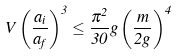Convert formula to latex. <formula><loc_0><loc_0><loc_500><loc_500>V \left ( \frac { a _ { i } } { a _ { f } } \right ) ^ { 3 } \leq \frac { \pi ^ { 2 } } { 3 0 } g \left ( \frac { m } { 2 g } \right ) ^ { 4 }</formula> 